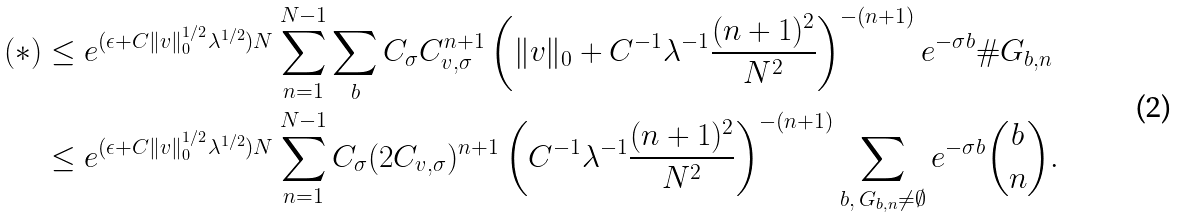<formula> <loc_0><loc_0><loc_500><loc_500>( * ) & \leq e ^ { ( \epsilon + C \| v \| _ { 0 } ^ { 1 / 2 } \lambda ^ { 1 / 2 } ) N } \sum _ { n = 1 } ^ { N - 1 } \sum _ { b } C _ { \sigma } C ^ { n + 1 } _ { v , \sigma } \left ( \| v \| _ { 0 } + C ^ { - 1 } \lambda ^ { - 1 } \frac { ( n + 1 ) ^ { 2 } } { N ^ { 2 } } \right ) ^ { - ( n + 1 ) } e ^ { - \sigma b } \# G _ { b , n } \\ & \leq e ^ { ( \epsilon + C \| v \| _ { 0 } ^ { 1 / 2 } \lambda ^ { 1 / 2 } ) N } \sum _ { n = 1 } ^ { N - 1 } C _ { \sigma } ( 2 C _ { v , \sigma } ) ^ { n + 1 } \left ( C ^ { - 1 } \lambda ^ { - 1 } \frac { ( n + 1 ) ^ { 2 } } { N ^ { 2 } } \right ) ^ { - ( n + 1 ) } \sum _ { b , \, G _ { b , n } \neq \emptyset } e ^ { - \sigma b } \binom { b } { n } .</formula> 